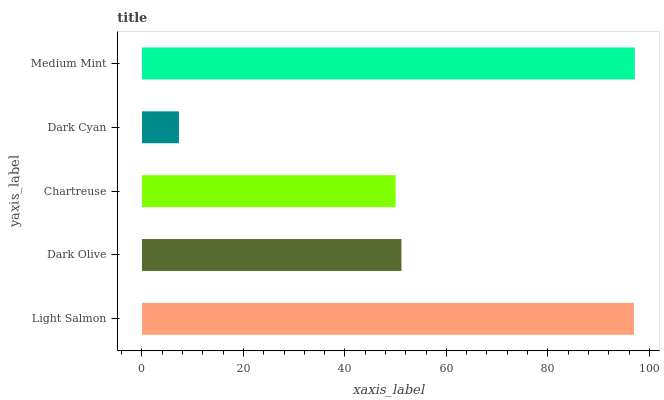Is Dark Cyan the minimum?
Answer yes or no. Yes. Is Medium Mint the maximum?
Answer yes or no. Yes. Is Dark Olive the minimum?
Answer yes or no. No. Is Dark Olive the maximum?
Answer yes or no. No. Is Light Salmon greater than Dark Olive?
Answer yes or no. Yes. Is Dark Olive less than Light Salmon?
Answer yes or no. Yes. Is Dark Olive greater than Light Salmon?
Answer yes or no. No. Is Light Salmon less than Dark Olive?
Answer yes or no. No. Is Dark Olive the high median?
Answer yes or no. Yes. Is Dark Olive the low median?
Answer yes or no. Yes. Is Light Salmon the high median?
Answer yes or no. No. Is Chartreuse the low median?
Answer yes or no. No. 